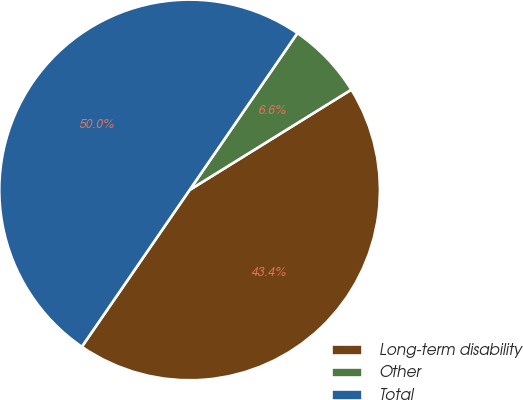Convert chart. <chart><loc_0><loc_0><loc_500><loc_500><pie_chart><fcel>Long-term disability<fcel>Other<fcel>Total<nl><fcel>43.42%<fcel>6.58%<fcel>50.0%<nl></chart> 